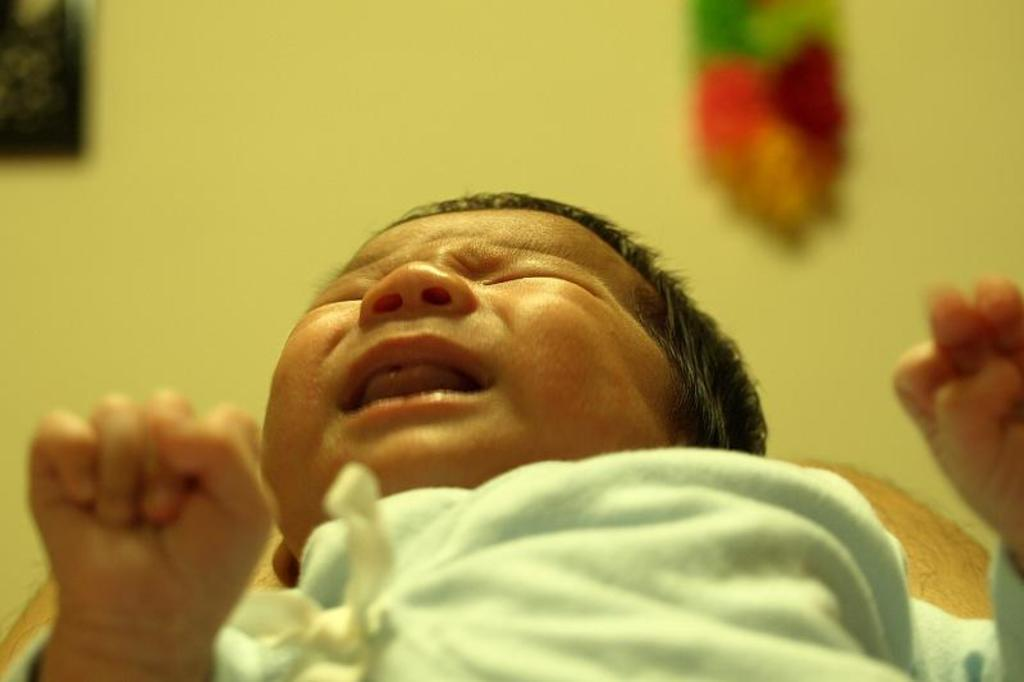What is the main subject of the picture? The main subject of the picture is a baby. What is the baby doing in the picture? The baby is crying in the picture. Can you describe the background of the image? The background of the image is blurred. What type of scent can be smelled coming from the baby in the image? There is no indication of a scent in the image, as it is a photograph and cannot convey smells. --- 